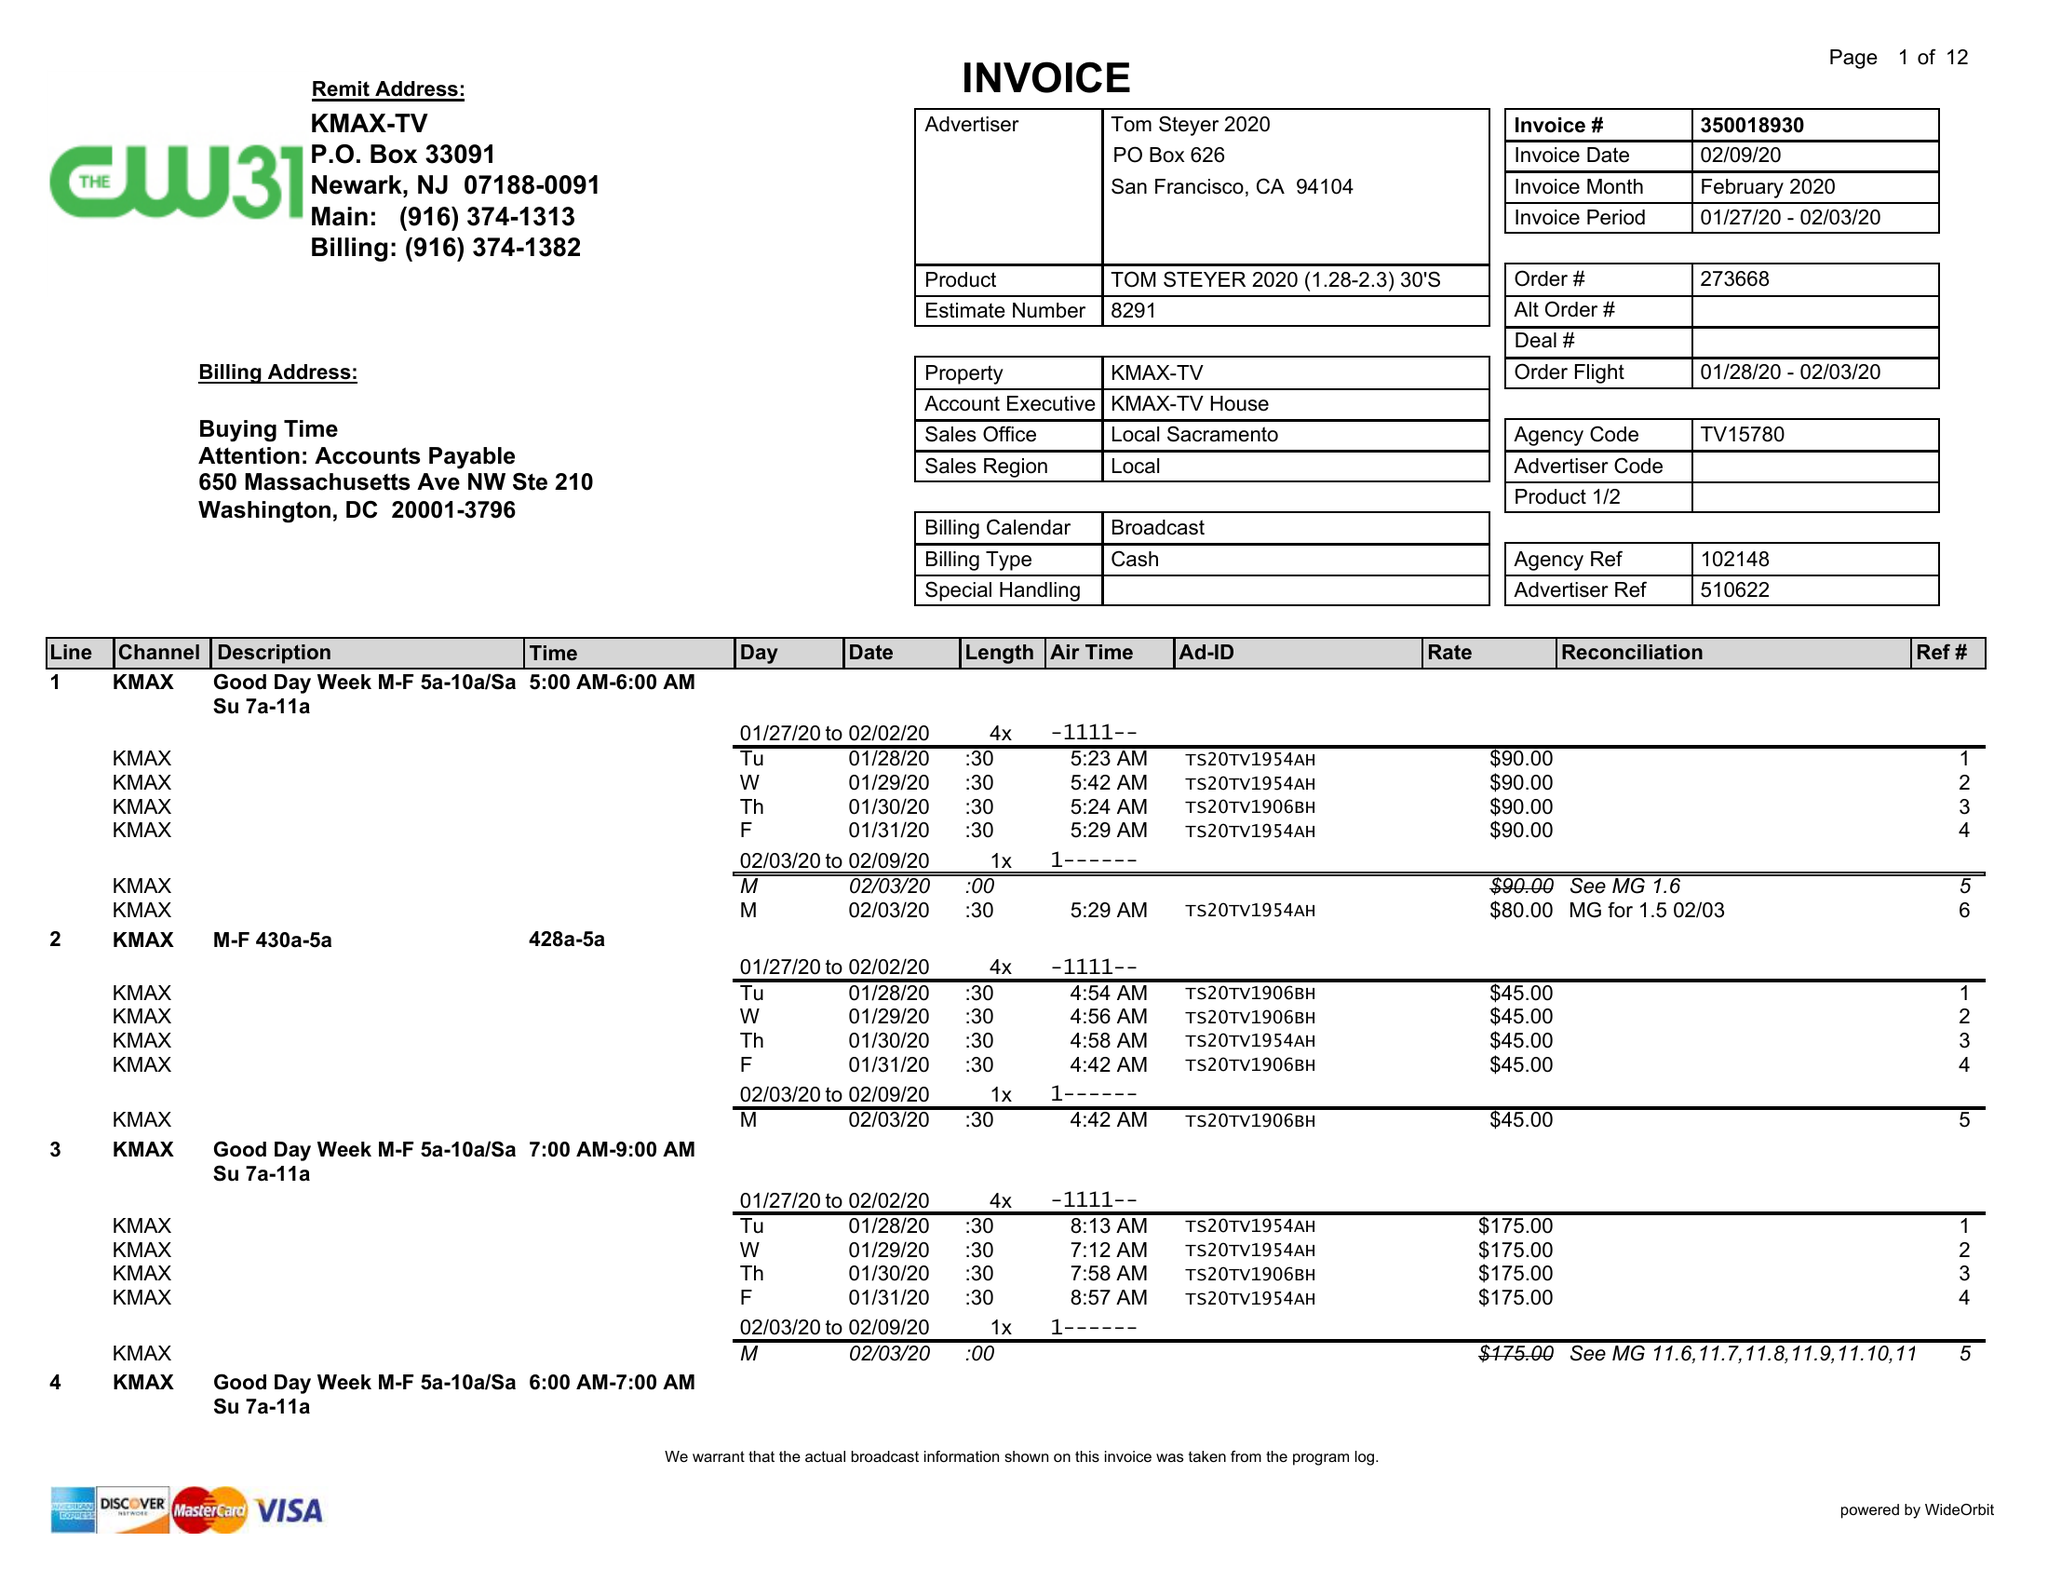What is the value for the gross_amount?
Answer the question using a single word or phrase. 16755.00 